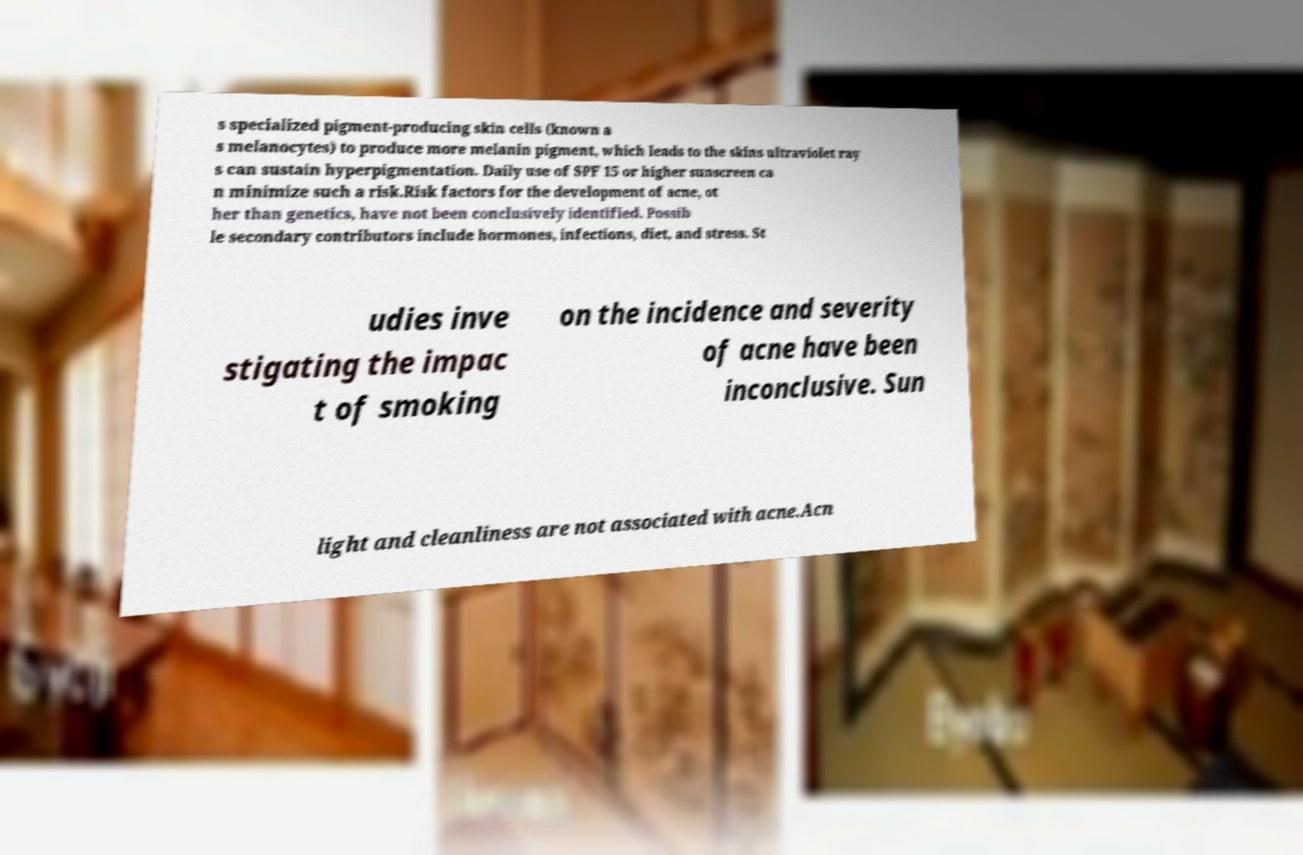Can you accurately transcribe the text from the provided image for me? s specialized pigment-producing skin cells (known a s melanocytes) to produce more melanin pigment, which leads to the skins ultraviolet ray s can sustain hyperpigmentation. Daily use of SPF 15 or higher sunscreen ca n minimize such a risk.Risk factors for the development of acne, ot her than genetics, have not been conclusively identified. Possib le secondary contributors include hormones, infections, diet, and stress. St udies inve stigating the impac t of smoking on the incidence and severity of acne have been inconclusive. Sun light and cleanliness are not associated with acne.Acn 